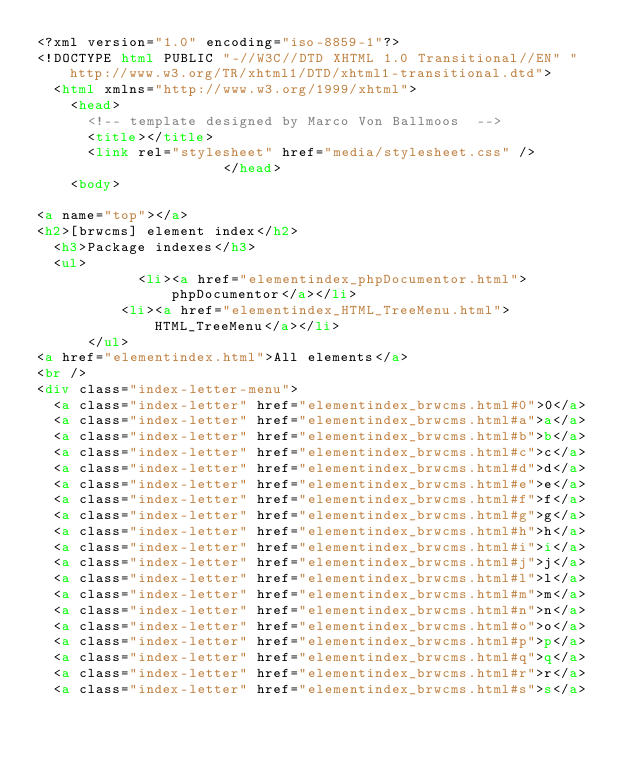Convert code to text. <code><loc_0><loc_0><loc_500><loc_500><_HTML_><?xml version="1.0" encoding="iso-8859-1"?>
<!DOCTYPE html PUBLIC "-//W3C//DTD XHTML 1.0 Transitional//EN" "http://www.w3.org/TR/xhtml1/DTD/xhtml1-transitional.dtd">
  <html xmlns="http://www.w3.org/1999/xhtml">
		<head>
			<!-- template designed by Marco Von Ballmoos  -->
			<title></title>
			<link rel="stylesheet" href="media/stylesheet.css" />
											</head>
		<body>
						<a name="top"></a>
<h2>[brwcms] element index</h2>
	<h3>Package indexes</h3>
	<ul>
						<li><a href="elementindex_phpDocumentor.html">phpDocumentor</a></li>
					<li><a href="elementindex_HTML_TreeMenu.html">HTML_TreeMenu</a></li>
			</ul>
<a href="elementindex.html">All elements</a>
<br />
<div class="index-letter-menu">
	<a class="index-letter" href="elementindex_brwcms.html#0">0</a>
	<a class="index-letter" href="elementindex_brwcms.html#a">a</a>
	<a class="index-letter" href="elementindex_brwcms.html#b">b</a>
	<a class="index-letter" href="elementindex_brwcms.html#c">c</a>
	<a class="index-letter" href="elementindex_brwcms.html#d">d</a>
	<a class="index-letter" href="elementindex_brwcms.html#e">e</a>
	<a class="index-letter" href="elementindex_brwcms.html#f">f</a>
	<a class="index-letter" href="elementindex_brwcms.html#g">g</a>
	<a class="index-letter" href="elementindex_brwcms.html#h">h</a>
	<a class="index-letter" href="elementindex_brwcms.html#i">i</a>
	<a class="index-letter" href="elementindex_brwcms.html#j">j</a>
	<a class="index-letter" href="elementindex_brwcms.html#l">l</a>
	<a class="index-letter" href="elementindex_brwcms.html#m">m</a>
	<a class="index-letter" href="elementindex_brwcms.html#n">n</a>
	<a class="index-letter" href="elementindex_brwcms.html#o">o</a>
	<a class="index-letter" href="elementindex_brwcms.html#p">p</a>
	<a class="index-letter" href="elementindex_brwcms.html#q">q</a>
	<a class="index-letter" href="elementindex_brwcms.html#r">r</a>
	<a class="index-letter" href="elementindex_brwcms.html#s">s</a></code> 